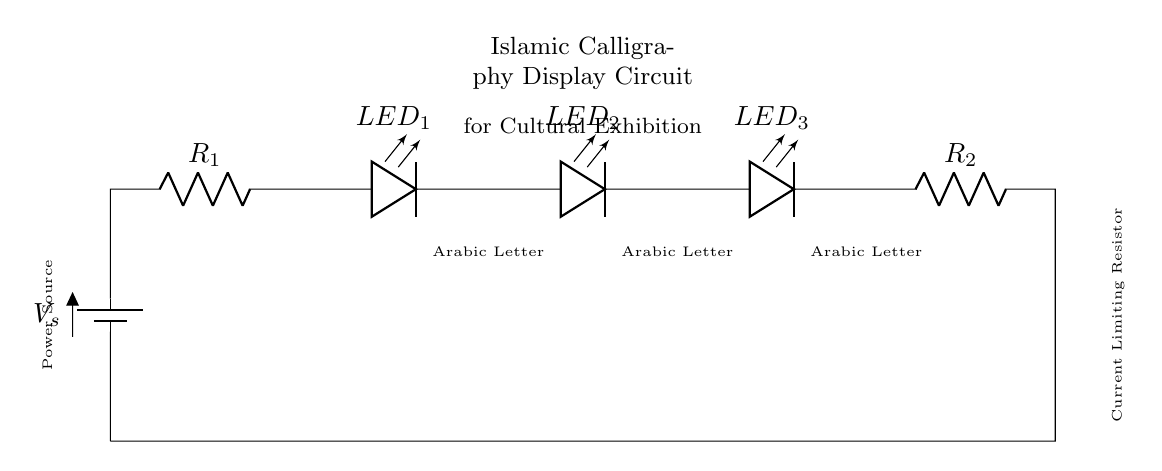What components are present in the circuit? The components include a power source (battery), resistors, and multiple LEDs. The diagram shows two resistors and three LEDs connected in series.
Answer: battery, resistors, LEDs How many LEDs are used in this circuit? The diagram clearly indicates that there are three LEDs in series, which are labeled as LED 1, LED 2, and LED 3.
Answer: 3 What type of circuit is this? This is a series circuit because all components are connected in a single path, meaning the same current flows through each component.
Answer: series What is the purpose of the resistors in this circuit? The resistors are used to limit the current passing through the LEDs to prevent them from burning out. This is essential for the longevity and proper functioning of the LEDs.
Answer: current limiting What happens if one LED fails in this series circuit? If one LED fails, it will break the circuit, causing all LEDs to turn off. This is characteristic of series circuits because current cannot pass through an open circuit.
Answer: all off What is the function of the power source? The power source provides the necessary voltage and current to drive the LEDs and allow them to illuminate. It is essential for powering the circuit.
Answer: power supply 